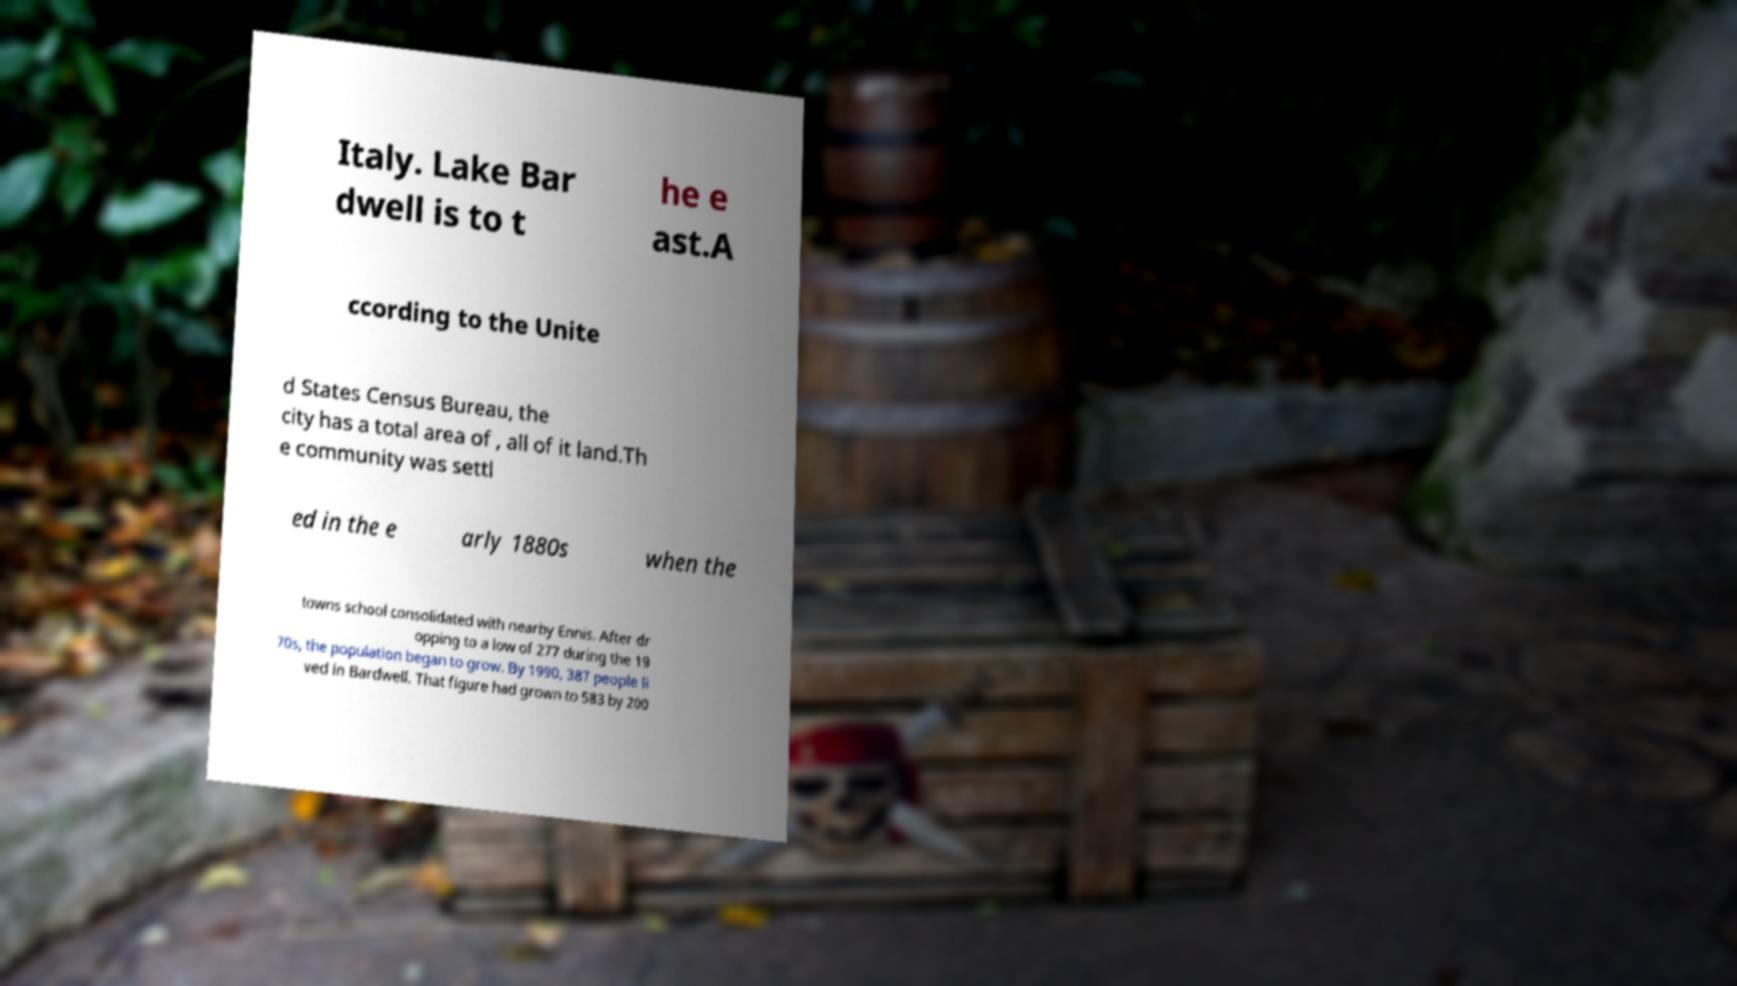For documentation purposes, I need the text within this image transcribed. Could you provide that? Italy. Lake Bar dwell is to t he e ast.A ccording to the Unite d States Census Bureau, the city has a total area of , all of it land.Th e community was settl ed in the e arly 1880s when the towns school consolidated with nearby Ennis. After dr opping to a low of 277 during the 19 70s, the population began to grow. By 1990, 387 people li ved in Bardwell. That figure had grown to 583 by 200 